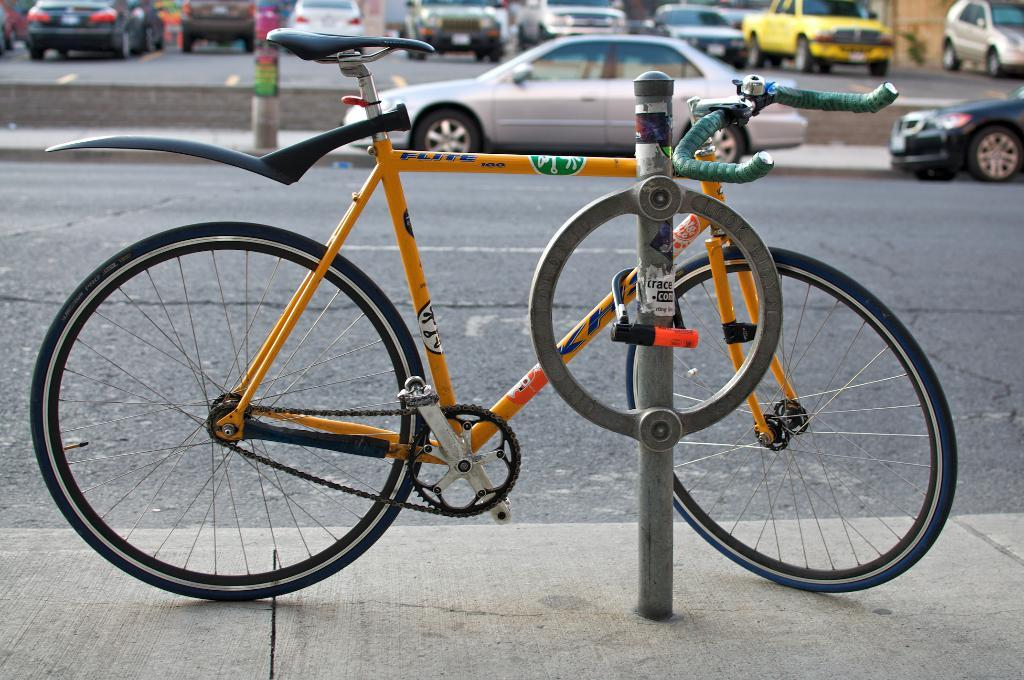What is located on the sidewalk in the image? There is a cycle on the sidewalk. What object can be seen in the image besides the cycle? There is a pole in the image. What can be seen in the distance behind the pole? There is a road visible in the background. What type of environment is depicted in the background? There are many vehicles in the background, suggesting a busy road or street. What type of grain is being crushed by the guitar in the image? There is no guitar or grain present in the image. 